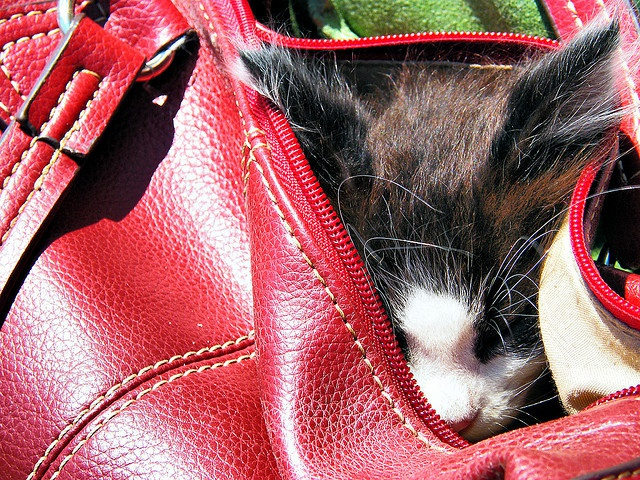Describe the objects in this image and their specific colors. I can see handbag in brown, white, salmon, black, and red tones and cat in brown, black, gray, white, and darkgray tones in this image. 